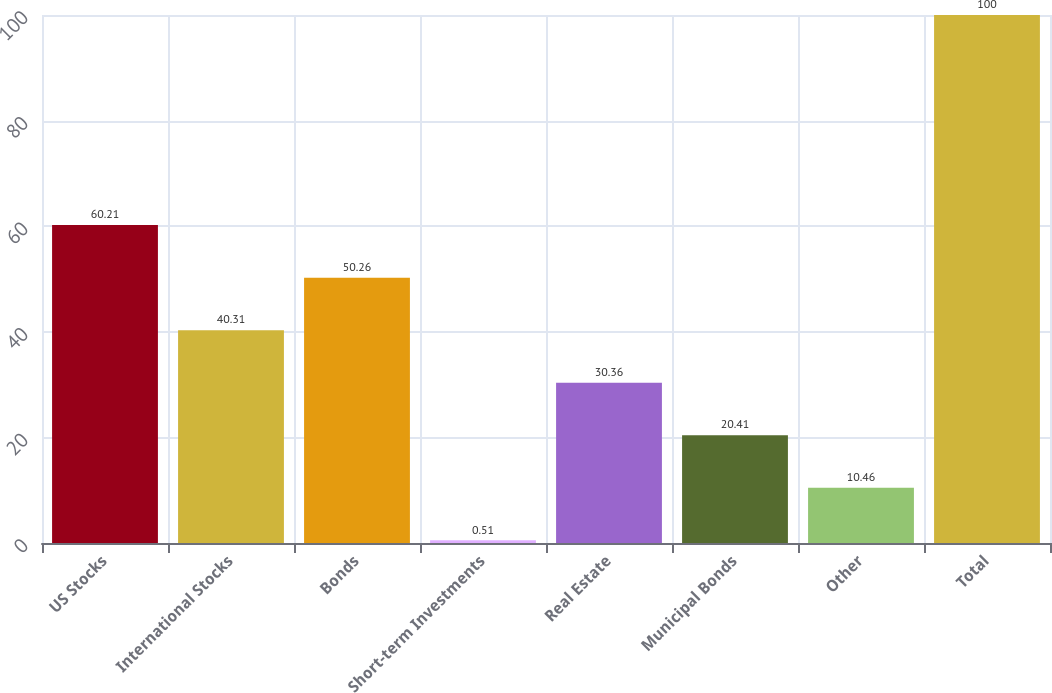<chart> <loc_0><loc_0><loc_500><loc_500><bar_chart><fcel>US Stocks<fcel>International Stocks<fcel>Bonds<fcel>Short-term Investments<fcel>Real Estate<fcel>Municipal Bonds<fcel>Other<fcel>Total<nl><fcel>60.21<fcel>40.31<fcel>50.26<fcel>0.51<fcel>30.36<fcel>20.41<fcel>10.46<fcel>100<nl></chart> 